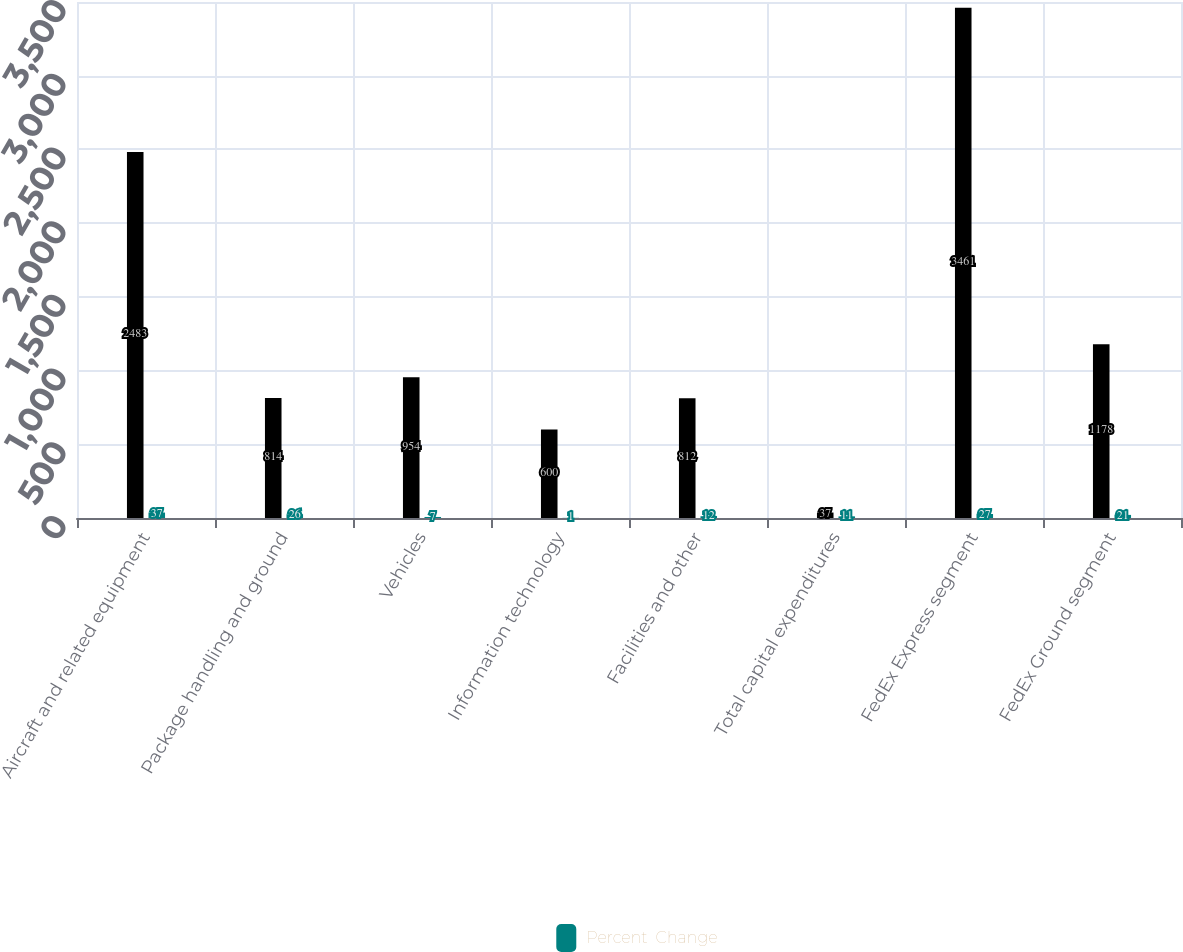Convert chart to OTSL. <chart><loc_0><loc_0><loc_500><loc_500><stacked_bar_chart><ecel><fcel>Aircraft and related equipment<fcel>Package handling and ground<fcel>Vehicles<fcel>Information technology<fcel>Facilities and other<fcel>Total capital expenditures<fcel>FedEx Express segment<fcel>FedEx Ground segment<nl><fcel>nan<fcel>2483<fcel>814<fcel>954<fcel>600<fcel>812<fcel>37<fcel>3461<fcel>1178<nl><fcel>Percent  Change<fcel>37<fcel>26<fcel>7<fcel>1<fcel>12<fcel>11<fcel>27<fcel>21<nl></chart> 